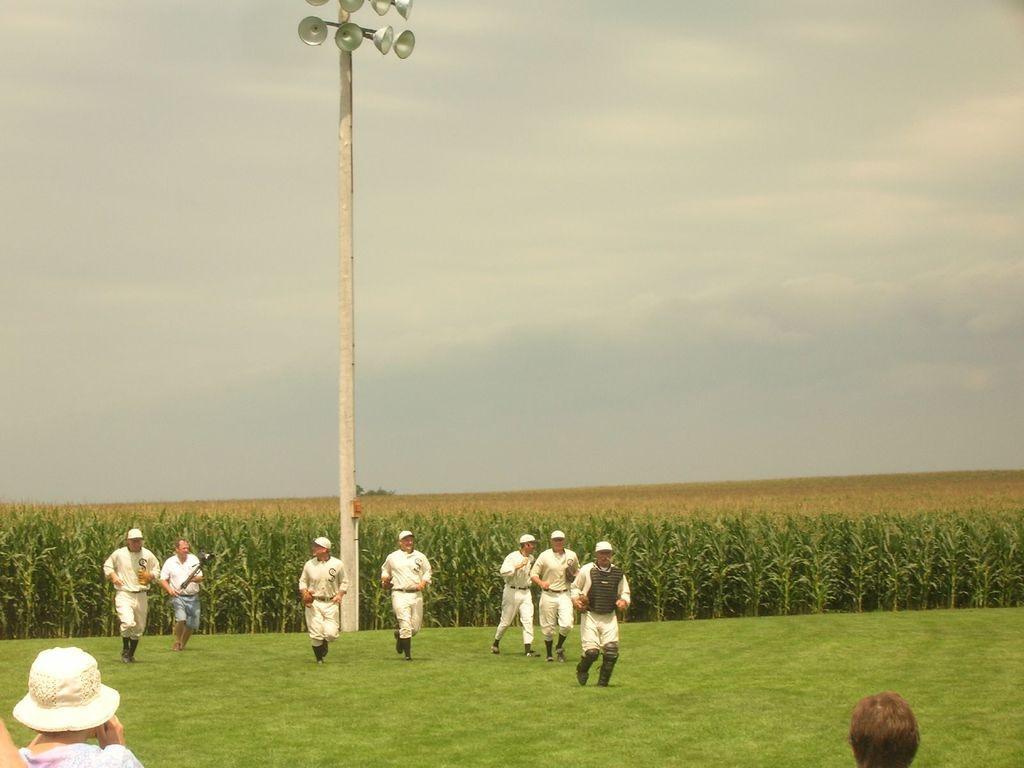How would you summarize this image in a sentence or two? There are few persons on the ground. Here we can see grass, field, pole, and lights. In the background there is sky. 